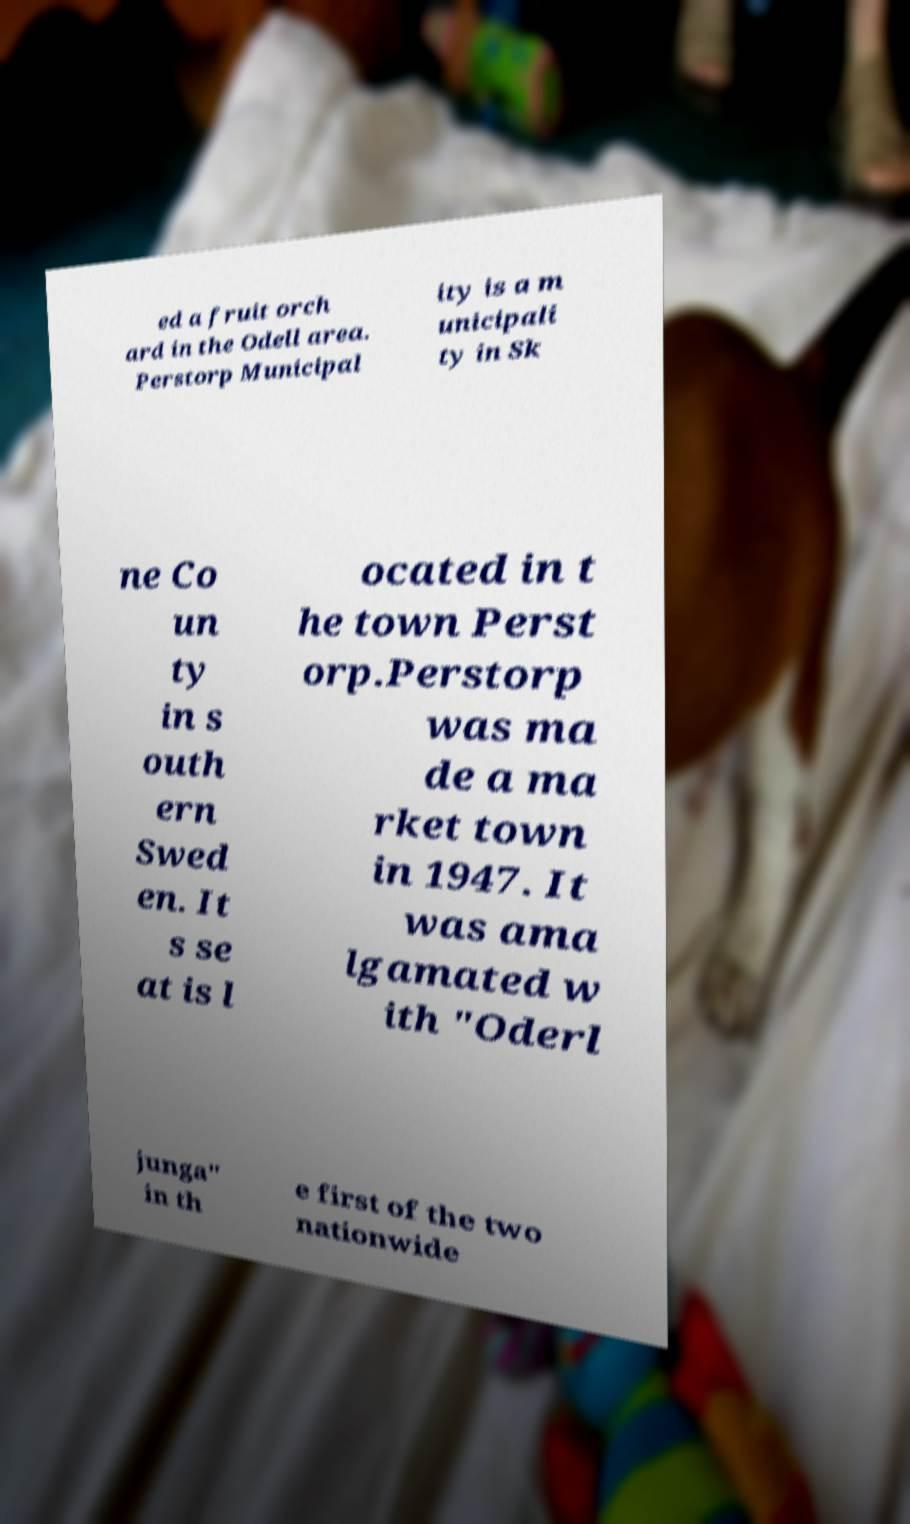Please identify and transcribe the text found in this image. ed a fruit orch ard in the Odell area. Perstorp Municipal ity is a m unicipali ty in Sk ne Co un ty in s outh ern Swed en. It s se at is l ocated in t he town Perst orp.Perstorp was ma de a ma rket town in 1947. It was ama lgamated w ith "Oderl junga" in th e first of the two nationwide 